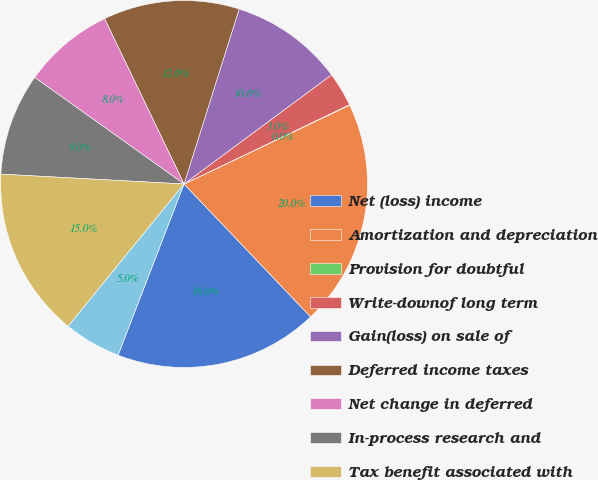<chart> <loc_0><loc_0><loc_500><loc_500><pie_chart><fcel>Net (loss) income<fcel>Amortization and depreciation<fcel>Provision for doubtful<fcel>Write-downof long term<fcel>Gain(loss) on sale of<fcel>Deferred income taxes<fcel>Net change in deferred<fcel>In-process research and<fcel>Tax benefit associated with<fcel>Accounts receivable<nl><fcel>17.97%<fcel>19.96%<fcel>0.04%<fcel>3.03%<fcel>10.0%<fcel>11.99%<fcel>8.01%<fcel>9.0%<fcel>14.98%<fcel>5.02%<nl></chart> 